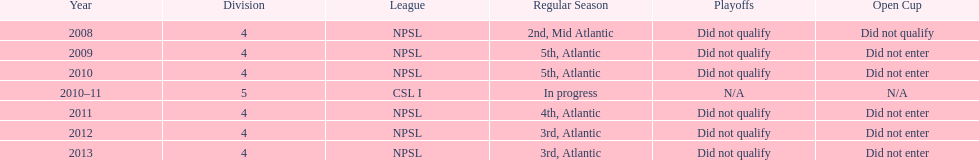What is the total number of 3rd place finishes for npsl? 2. 